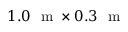Convert formula to latex. <formula><loc_0><loc_0><loc_500><loc_500>1 . 0 m \times 0 . 3 m</formula> 